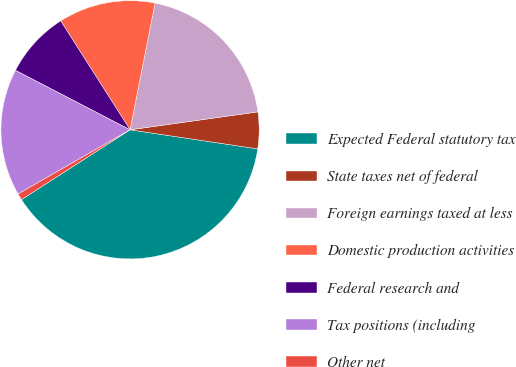Convert chart to OTSL. <chart><loc_0><loc_0><loc_500><loc_500><pie_chart><fcel>Expected Federal statutory tax<fcel>State taxes net of federal<fcel>Foreign earnings taxed at less<fcel>Domestic production activities<fcel>Federal research and<fcel>Tax positions (including<fcel>Other net<nl><fcel>38.55%<fcel>4.58%<fcel>19.68%<fcel>12.13%<fcel>8.36%<fcel>15.9%<fcel>0.81%<nl></chart> 